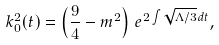<formula> <loc_0><loc_0><loc_500><loc_500>k ^ { 2 } _ { 0 } ( t ) = \left ( \frac { 9 } { 4 } - m ^ { 2 } \right ) \, e ^ { 2 \int \sqrt { \Lambda / 3 } d t } ,</formula> 